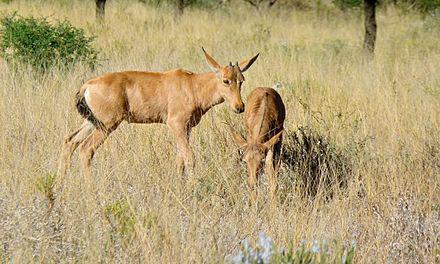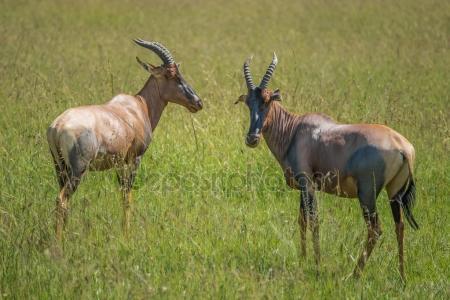The first image is the image on the left, the second image is the image on the right. Evaluate the accuracy of this statement regarding the images: "The right image contains at least twice as many hooved animals as the left image.". Is it true? Answer yes or no. No. The first image is the image on the left, the second image is the image on the right. For the images shown, is this caption "There is a grand total of 4 animals between both pictures." true? Answer yes or no. Yes. 